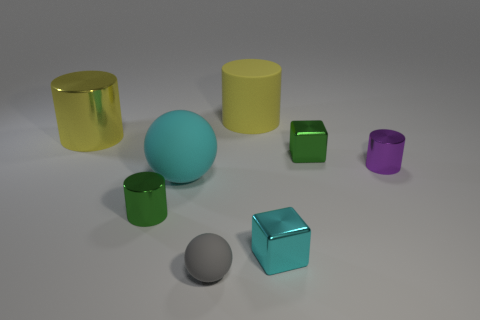Comparing the sizes, could the smaller green cylinder fit into the larger gold one? If we observe their proportions, it appears that the smaller green cylinder could indeed fit inside the larger gold one, as the gold cylinder has a wider diameter and seems tall enough to accommodate the green cylinder's height. 